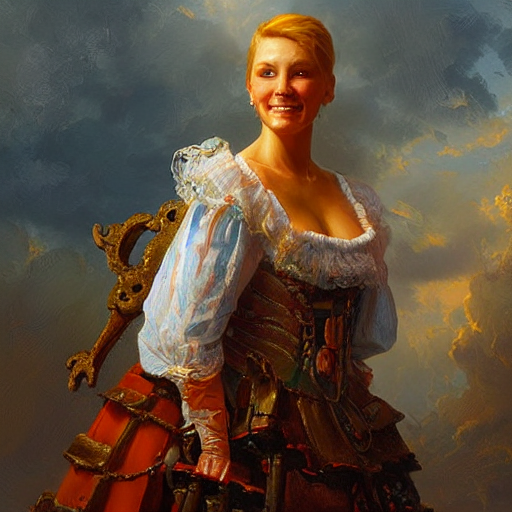How does the person's expression contribute to the mood of the painting? The person’s expression is one of gentle contentment—with a soft smile and bright eyes—a mood that is reinforced by the lighting of the scene. This expression, combined with the ambient lighting, adds to the serene and positive atmosphere of the painting. 